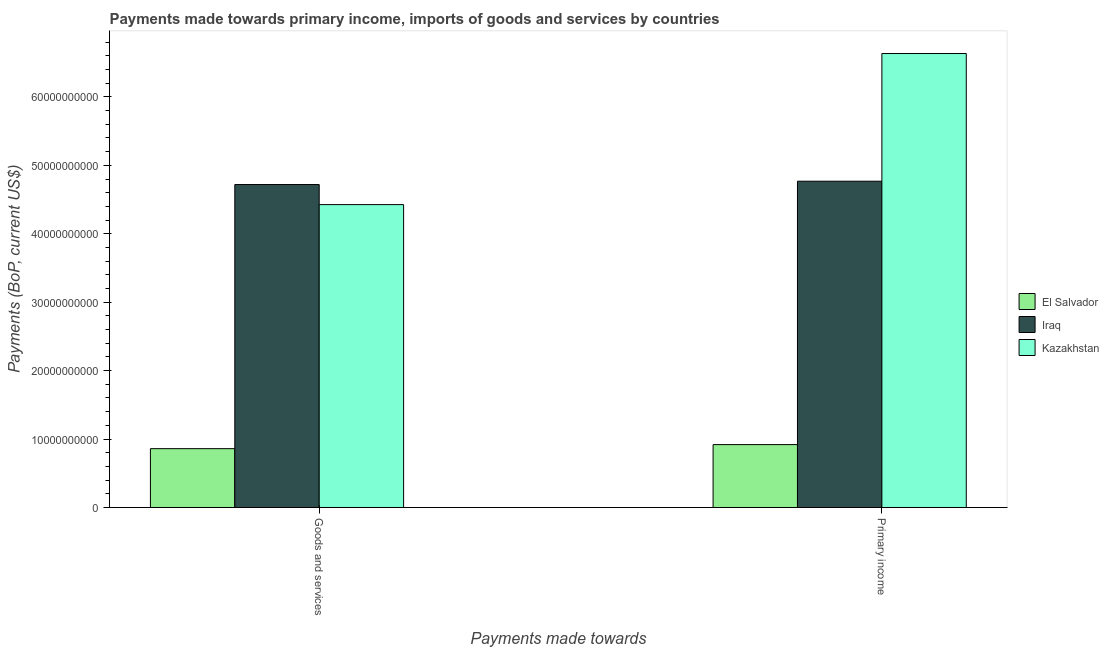How many different coloured bars are there?
Provide a short and direct response. 3. How many bars are there on the 1st tick from the left?
Offer a terse response. 3. What is the label of the 2nd group of bars from the left?
Make the answer very short. Primary income. What is the payments made towards primary income in Kazakhstan?
Offer a very short reply. 6.63e+1. Across all countries, what is the maximum payments made towards goods and services?
Provide a short and direct response. 4.72e+1. Across all countries, what is the minimum payments made towards primary income?
Your response must be concise. 9.19e+09. In which country was the payments made towards goods and services maximum?
Your answer should be very brief. Iraq. In which country was the payments made towards primary income minimum?
Make the answer very short. El Salvador. What is the total payments made towards goods and services in the graph?
Provide a succinct answer. 1.00e+11. What is the difference between the payments made towards primary income in Kazakhstan and that in El Salvador?
Offer a terse response. 5.71e+1. What is the difference between the payments made towards primary income in Iraq and the payments made towards goods and services in El Salvador?
Keep it short and to the point. 3.91e+1. What is the average payments made towards primary income per country?
Provide a short and direct response. 4.11e+1. What is the difference between the payments made towards goods and services and payments made towards primary income in El Salvador?
Ensure brevity in your answer.  -5.95e+08. What is the ratio of the payments made towards goods and services in Kazakhstan to that in El Salvador?
Provide a succinct answer. 5.15. Is the payments made towards goods and services in Iraq less than that in Kazakhstan?
Your response must be concise. No. What does the 3rd bar from the left in Goods and services represents?
Ensure brevity in your answer.  Kazakhstan. What does the 2nd bar from the right in Primary income represents?
Offer a terse response. Iraq. How many bars are there?
Your response must be concise. 6. Are all the bars in the graph horizontal?
Make the answer very short. No. What is the difference between two consecutive major ticks on the Y-axis?
Make the answer very short. 1.00e+1. Does the graph contain grids?
Offer a very short reply. No. How are the legend labels stacked?
Provide a succinct answer. Vertical. What is the title of the graph?
Make the answer very short. Payments made towards primary income, imports of goods and services by countries. Does "Timor-Leste" appear as one of the legend labels in the graph?
Make the answer very short. No. What is the label or title of the X-axis?
Offer a very short reply. Payments made towards. What is the label or title of the Y-axis?
Ensure brevity in your answer.  Payments (BoP, current US$). What is the Payments (BoP, current US$) in El Salvador in Goods and services?
Provide a short and direct response. 8.60e+09. What is the Payments (BoP, current US$) of Iraq in Goods and services?
Give a very brief answer. 4.72e+1. What is the Payments (BoP, current US$) of Kazakhstan in Goods and services?
Ensure brevity in your answer.  4.43e+1. What is the Payments (BoP, current US$) in El Salvador in Primary income?
Give a very brief answer. 9.19e+09. What is the Payments (BoP, current US$) of Iraq in Primary income?
Your response must be concise. 4.77e+1. What is the Payments (BoP, current US$) in Kazakhstan in Primary income?
Your answer should be very brief. 6.63e+1. Across all Payments made towards, what is the maximum Payments (BoP, current US$) in El Salvador?
Your answer should be very brief. 9.19e+09. Across all Payments made towards, what is the maximum Payments (BoP, current US$) of Iraq?
Ensure brevity in your answer.  4.77e+1. Across all Payments made towards, what is the maximum Payments (BoP, current US$) in Kazakhstan?
Provide a short and direct response. 6.63e+1. Across all Payments made towards, what is the minimum Payments (BoP, current US$) of El Salvador?
Your answer should be compact. 8.60e+09. Across all Payments made towards, what is the minimum Payments (BoP, current US$) in Iraq?
Give a very brief answer. 4.72e+1. Across all Payments made towards, what is the minimum Payments (BoP, current US$) of Kazakhstan?
Keep it short and to the point. 4.43e+1. What is the total Payments (BoP, current US$) in El Salvador in the graph?
Offer a terse response. 1.78e+1. What is the total Payments (BoP, current US$) of Iraq in the graph?
Ensure brevity in your answer.  9.49e+1. What is the total Payments (BoP, current US$) in Kazakhstan in the graph?
Your response must be concise. 1.11e+11. What is the difference between the Payments (BoP, current US$) in El Salvador in Goods and services and that in Primary income?
Give a very brief answer. -5.95e+08. What is the difference between the Payments (BoP, current US$) in Iraq in Goods and services and that in Primary income?
Provide a short and direct response. -4.87e+08. What is the difference between the Payments (BoP, current US$) of Kazakhstan in Goods and services and that in Primary income?
Your answer should be very brief. -2.21e+1. What is the difference between the Payments (BoP, current US$) in El Salvador in Goods and services and the Payments (BoP, current US$) in Iraq in Primary income?
Keep it short and to the point. -3.91e+1. What is the difference between the Payments (BoP, current US$) of El Salvador in Goods and services and the Payments (BoP, current US$) of Kazakhstan in Primary income?
Provide a short and direct response. -5.77e+1. What is the difference between the Payments (BoP, current US$) in Iraq in Goods and services and the Payments (BoP, current US$) in Kazakhstan in Primary income?
Your answer should be compact. -1.91e+1. What is the average Payments (BoP, current US$) in El Salvador per Payments made towards?
Your answer should be compact. 8.89e+09. What is the average Payments (BoP, current US$) in Iraq per Payments made towards?
Your answer should be compact. 4.74e+1. What is the average Payments (BoP, current US$) of Kazakhstan per Payments made towards?
Make the answer very short. 5.53e+1. What is the difference between the Payments (BoP, current US$) in El Salvador and Payments (BoP, current US$) in Iraq in Goods and services?
Your response must be concise. -3.86e+1. What is the difference between the Payments (BoP, current US$) in El Salvador and Payments (BoP, current US$) in Kazakhstan in Goods and services?
Ensure brevity in your answer.  -3.57e+1. What is the difference between the Payments (BoP, current US$) in Iraq and Payments (BoP, current US$) in Kazakhstan in Goods and services?
Make the answer very short. 2.93e+09. What is the difference between the Payments (BoP, current US$) in El Salvador and Payments (BoP, current US$) in Iraq in Primary income?
Provide a succinct answer. -3.85e+1. What is the difference between the Payments (BoP, current US$) in El Salvador and Payments (BoP, current US$) in Kazakhstan in Primary income?
Provide a succinct answer. -5.71e+1. What is the difference between the Payments (BoP, current US$) in Iraq and Payments (BoP, current US$) in Kazakhstan in Primary income?
Your answer should be very brief. -1.87e+1. What is the ratio of the Payments (BoP, current US$) of El Salvador in Goods and services to that in Primary income?
Provide a succinct answer. 0.94. What is the ratio of the Payments (BoP, current US$) of Iraq in Goods and services to that in Primary income?
Give a very brief answer. 0.99. What is the ratio of the Payments (BoP, current US$) of Kazakhstan in Goods and services to that in Primary income?
Offer a terse response. 0.67. What is the difference between the highest and the second highest Payments (BoP, current US$) in El Salvador?
Provide a short and direct response. 5.95e+08. What is the difference between the highest and the second highest Payments (BoP, current US$) in Iraq?
Keep it short and to the point. 4.87e+08. What is the difference between the highest and the second highest Payments (BoP, current US$) of Kazakhstan?
Ensure brevity in your answer.  2.21e+1. What is the difference between the highest and the lowest Payments (BoP, current US$) in El Salvador?
Your answer should be compact. 5.95e+08. What is the difference between the highest and the lowest Payments (BoP, current US$) in Iraq?
Keep it short and to the point. 4.87e+08. What is the difference between the highest and the lowest Payments (BoP, current US$) of Kazakhstan?
Your answer should be very brief. 2.21e+1. 